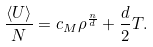<formula> <loc_0><loc_0><loc_500><loc_500>\frac { \langle U \rangle } { N } = c _ { M } \rho ^ { \frac { n } { d } } + \frac { d } { 2 } T .</formula> 